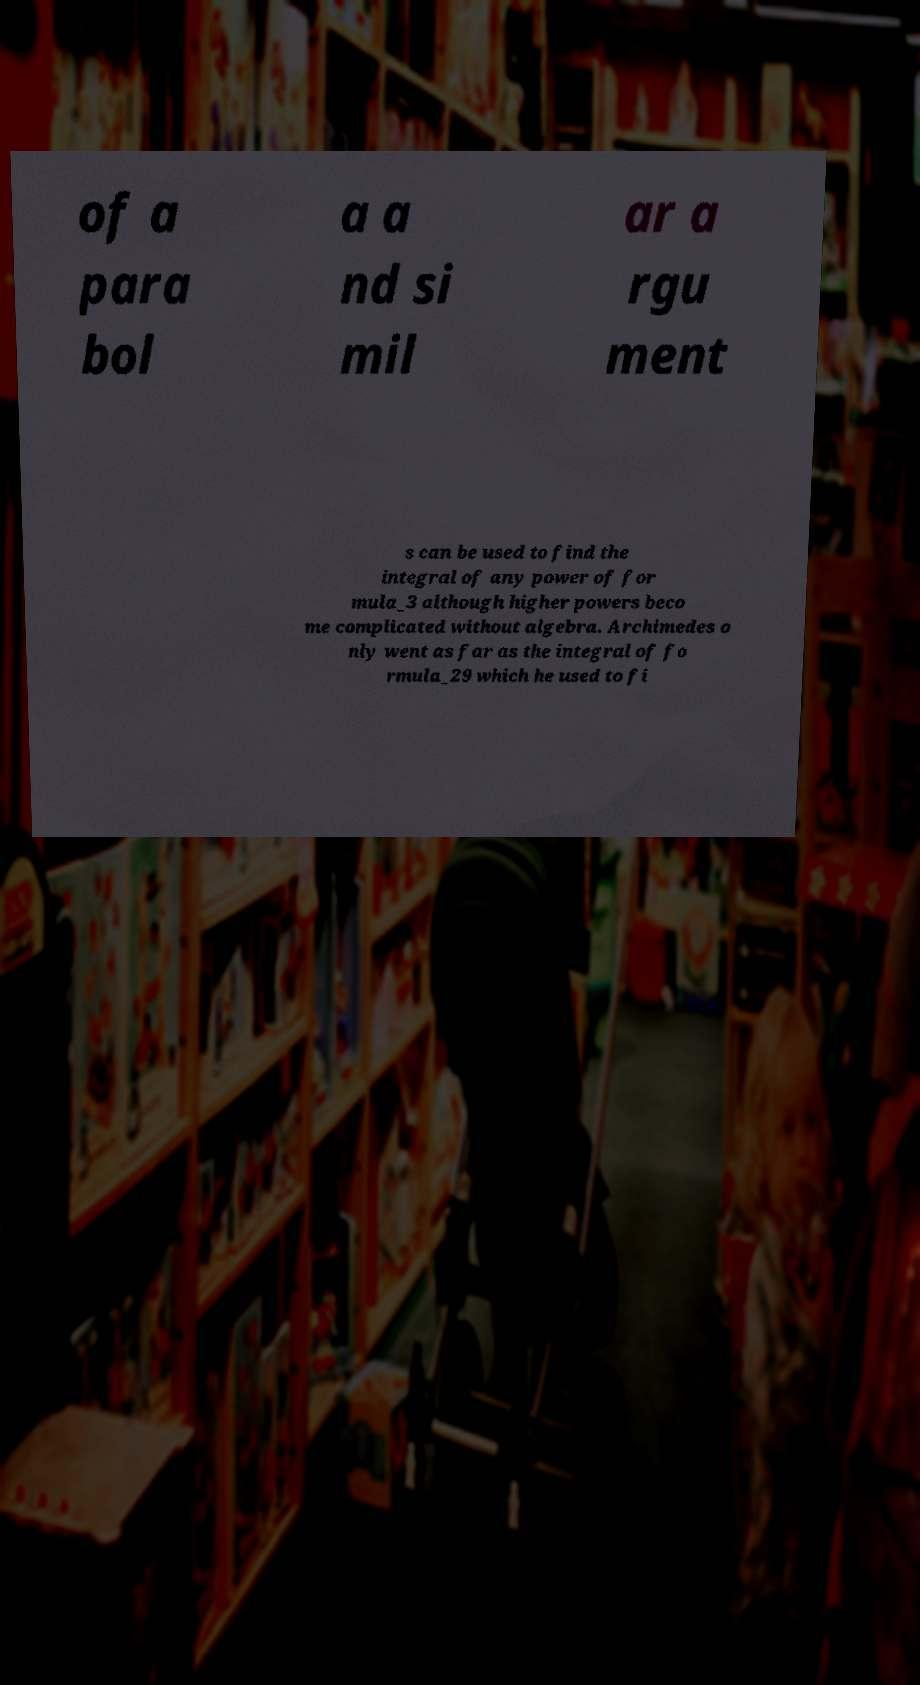There's text embedded in this image that I need extracted. Can you transcribe it verbatim? of a para bol a a nd si mil ar a rgu ment s can be used to find the integral of any power of for mula_3 although higher powers beco me complicated without algebra. Archimedes o nly went as far as the integral of fo rmula_29 which he used to fi 